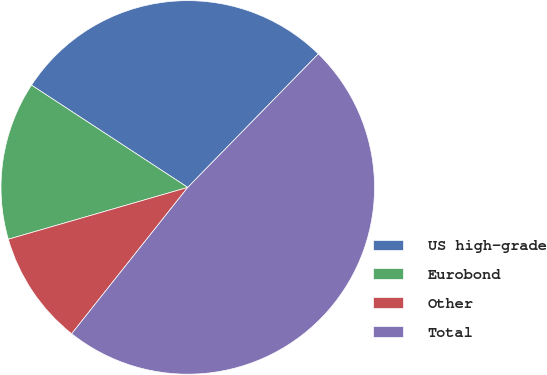Convert chart to OTSL. <chart><loc_0><loc_0><loc_500><loc_500><pie_chart><fcel>US high-grade<fcel>Eurobond<fcel>Other<fcel>Total<nl><fcel>28.1%<fcel>13.7%<fcel>9.85%<fcel>48.35%<nl></chart> 